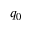Convert formula to latex. <formula><loc_0><loc_0><loc_500><loc_500>q _ { 0 }</formula> 